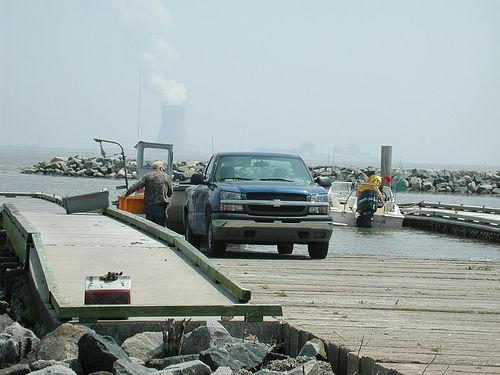Question: where is the truck?
Choices:
A. Highway.
B. Driveway.
C. Dock.
D. Bridge.
Answer with the letter. Answer: C Question: what kind of dock is there?
Choices:
A. Boat.
B. Swimming.
C. Restaurant.
D. Fishing.
Answer with the letter. Answer: A Question: what is in the water?
Choices:
A. Dolphins.
B. Turtles.
C. Boat.
D. Children.
Answer with the letter. Answer: C Question: how many trucks are there?
Choices:
A. 5.
B. 4.
C. 1.
D. 3.
Answer with the letter. Answer: C 